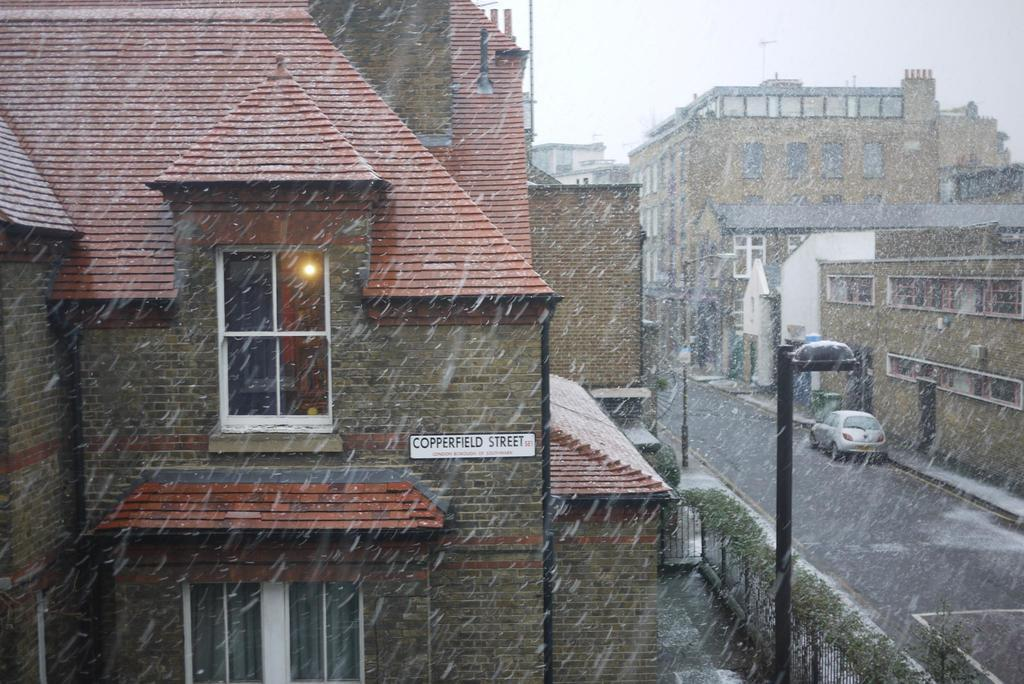What is the main subject of the image? The main subject of the image is a car on the road. What can be seen on the left side of the image? There are buildings on the left side of the image. What can be seen on the right side of the image? There are buildings on the right side of the image. Can you see a zipper on the car in the image? No, there is no zipper present on the car in the image. Are there any people kissing in the image? No, there are no people kissing in the image. 